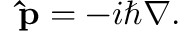Convert formula to latex. <formula><loc_0><loc_0><loc_500><loc_500>\hat { p } = - i \hbar { \nabla } .</formula> 